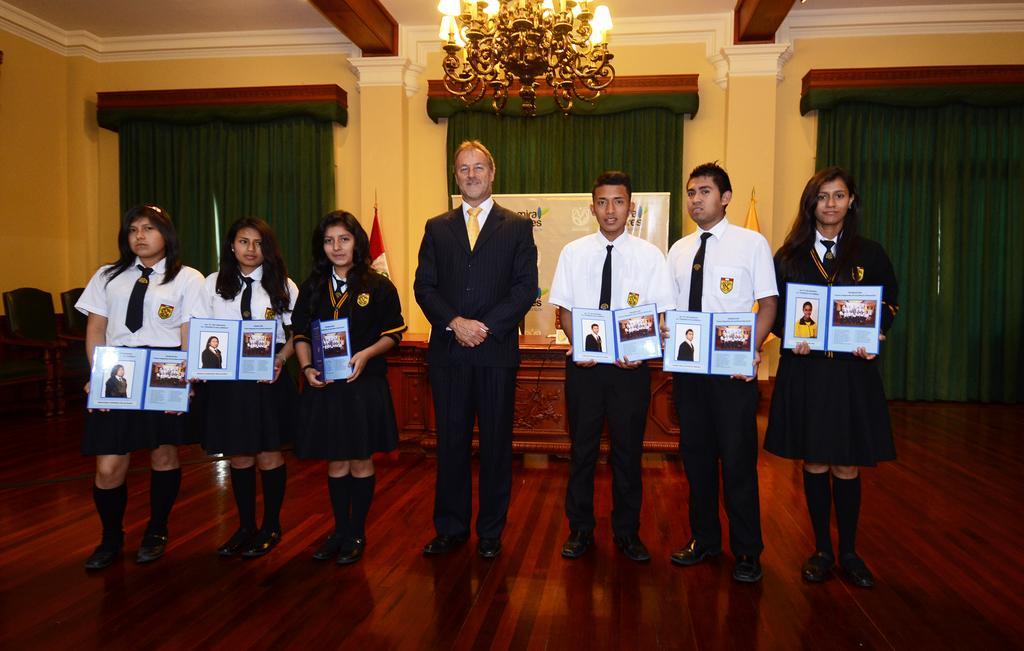Could you give a brief overview of what you see in this image? In this image we can see a man is standing, wearing suit. To the both side of the man, two boys and four girls are standing by holding books in there hand. Background one table is present and one banner is there. The walls of the room is in yellow color and the curtains are in green color. And on the roof chandelier is attached. 